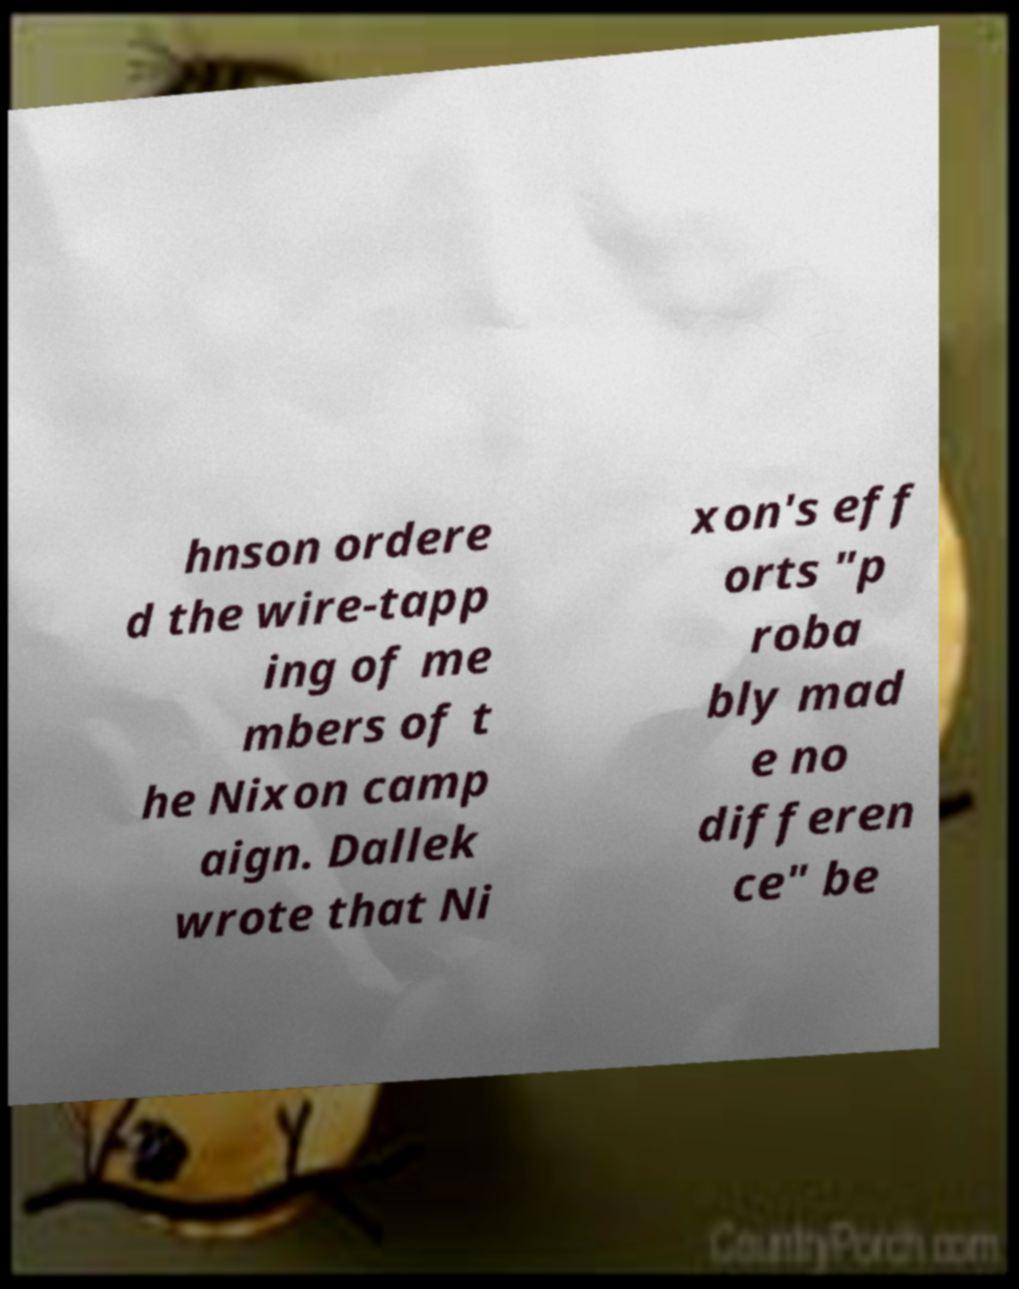What messages or text are displayed in this image? I need them in a readable, typed format. hnson ordere d the wire-tapp ing of me mbers of t he Nixon camp aign. Dallek wrote that Ni xon's eff orts "p roba bly mad e no differen ce" be 